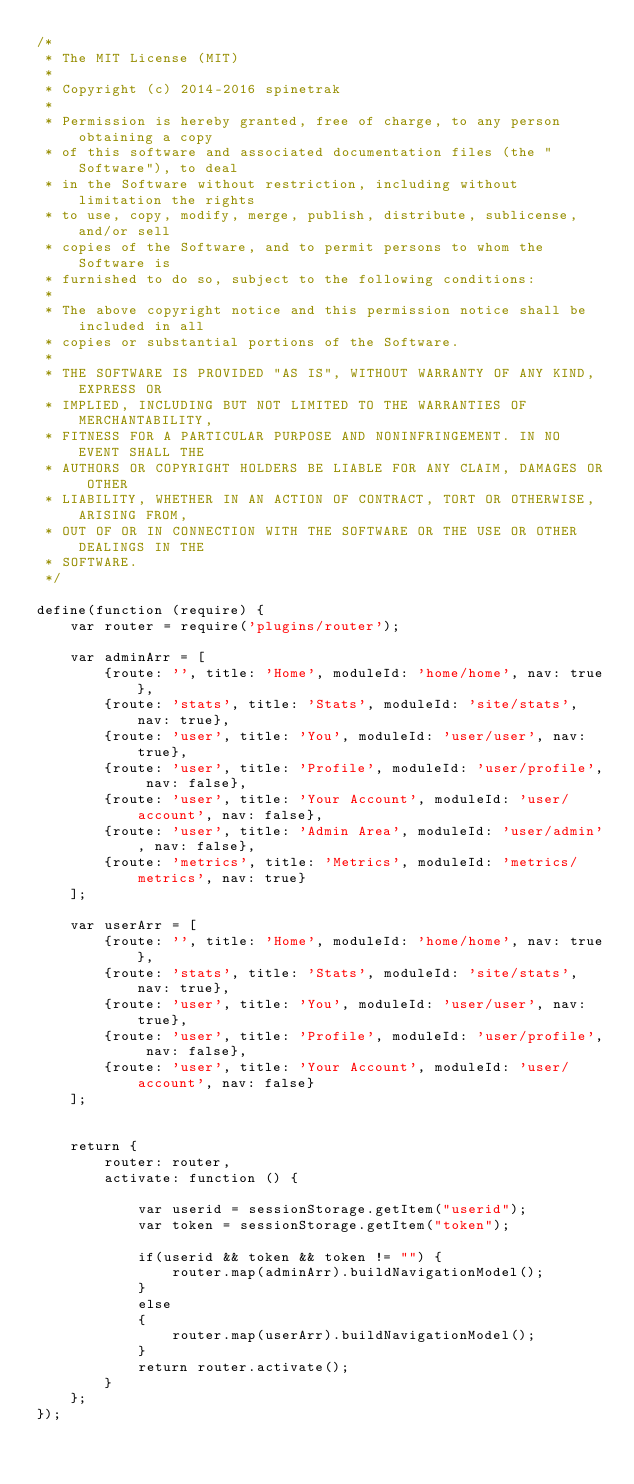Convert code to text. <code><loc_0><loc_0><loc_500><loc_500><_JavaScript_>/*
 * The MIT License (MIT)
 *
 * Copyright (c) 2014-2016 spinetrak
 *
 * Permission is hereby granted, free of charge, to any person obtaining a copy
 * of this software and associated documentation files (the "Software"), to deal
 * in the Software without restriction, including without limitation the rights
 * to use, copy, modify, merge, publish, distribute, sublicense, and/or sell
 * copies of the Software, and to permit persons to whom the Software is
 * furnished to do so, subject to the following conditions:
 *
 * The above copyright notice and this permission notice shall be included in all
 * copies or substantial portions of the Software.
 *
 * THE SOFTWARE IS PROVIDED "AS IS", WITHOUT WARRANTY OF ANY KIND, EXPRESS OR
 * IMPLIED, INCLUDING BUT NOT LIMITED TO THE WARRANTIES OF MERCHANTABILITY,
 * FITNESS FOR A PARTICULAR PURPOSE AND NONINFRINGEMENT. IN NO EVENT SHALL THE
 * AUTHORS OR COPYRIGHT HOLDERS BE LIABLE FOR ANY CLAIM, DAMAGES OR OTHER
 * LIABILITY, WHETHER IN AN ACTION OF CONTRACT, TORT OR OTHERWISE, ARISING FROM,
 * OUT OF OR IN CONNECTION WITH THE SOFTWARE OR THE USE OR OTHER DEALINGS IN THE
 * SOFTWARE.
 */

define(function (require) {
    var router = require('plugins/router');

    var adminArr = [
        {route: '', title: 'Home', moduleId: 'home/home', nav: true},
        {route: 'stats', title: 'Stats', moduleId: 'site/stats', nav: true},
        {route: 'user', title: 'You', moduleId: 'user/user', nav: true},
        {route: 'user', title: 'Profile', moduleId: 'user/profile', nav: false},
        {route: 'user', title: 'Your Account', moduleId: 'user/account', nav: false},
        {route: 'user', title: 'Admin Area', moduleId: 'user/admin', nav: false},
        {route: 'metrics', title: 'Metrics', moduleId: 'metrics/metrics', nav: true}
    ];

    var userArr = [
        {route: '', title: 'Home', moduleId: 'home/home', nav: true},
        {route: 'stats', title: 'Stats', moduleId: 'site/stats', nav: true},
        {route: 'user', title: 'You', moduleId: 'user/user', nav: true},
        {route: 'user', title: 'Profile', moduleId: 'user/profile', nav: false},
        {route: 'user', title: 'Your Account', moduleId: 'user/account', nav: false}
    ];


    return {
        router: router,
        activate: function () {

            var userid = sessionStorage.getItem("userid");
            var token = sessionStorage.getItem("token");

            if(userid && token && token != "") {
                router.map(adminArr).buildNavigationModel();
            }
            else
            {
                router.map(userArr).buildNavigationModel();
            }
            return router.activate();
        }
    };
});</code> 